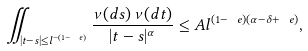Convert formula to latex. <formula><loc_0><loc_0><loc_500><loc_500>\iint _ { | t - s | \leq l ^ { - ( 1 - \ e ) } } \frac { \nu ( d s ) \, \nu ( d t ) } { | t - s | ^ { \alpha } } \leq A l ^ { ( 1 - \ e ) ( \alpha - \delta + \ e ) } ,</formula> 